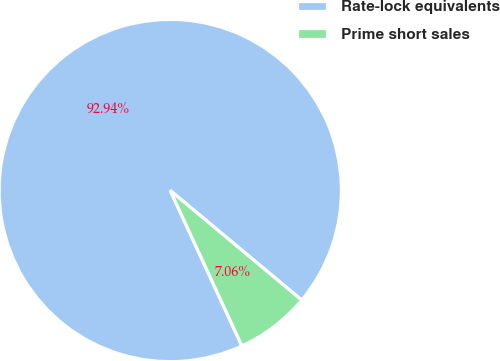Convert chart. <chart><loc_0><loc_0><loc_500><loc_500><pie_chart><fcel>Rate-lock equivalents<fcel>Prime short sales<nl><fcel>92.94%<fcel>7.06%<nl></chart> 